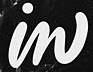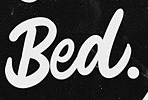Transcribe the words shown in these images in order, separated by a semicolon. in; Bed. 